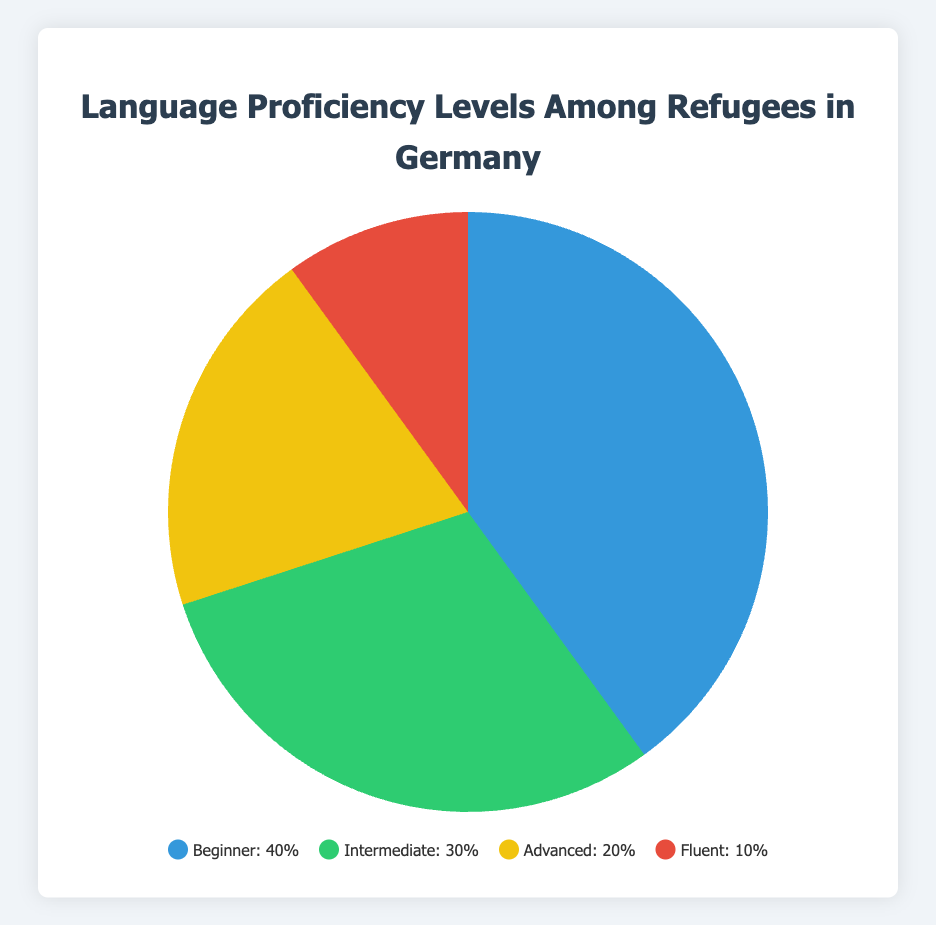What's the most common language proficiency level among refugees in Germany? The data shows that the highest percentage is 40%, attributed to the Beginner level, indicating that it is the most common proficiency level among refugees.
Answer: Beginner Which language proficiency level has the smallest percentage? The data indicates that the Fluent level has the smallest percentage at 10%.
Answer: Fluent What is the combined percentage of Intermediate and Advanced proficiency levels? The Intermediate level is 30% and the Advanced level is 20%. Adding them together gives 30% + 20% = 50%.
Answer: 50% What is the difference in percentage between the Beginner and Fluent proficiency levels? The Beginner level is 40%, and the Fluent level is 10%. The difference is 40% - 10% = 30%.
Answer: 30% What percentage is represented by the Beginner and Fluent levels combined? The Beginner level is 40%, and the Fluent level is 10%. Together, they represent 40% + 10% = 50%.
Answer: 50% How much more common is the Beginner level compared to the Advanced level? The Beginner level is at 40%, and the Advanced level is at 20%. The Beginner level is 20% more common than the Advanced level (40% - 20% = 20%).
Answer: 20% What percentage of refugees have at least an Intermediate proficiency level? The Intermediate, Advanced, and Fluent levels together account for 30% + 20% + 10% = 60%.
Answer: 60% Which proficiency level is represented by the blue color in the chart? Observing the visual attributes, the blue color corresponds to the Beginner proficiency level, which is 40%.
Answer: Beginner If we sum the percentages of the top two proficiency levels, what do we get? The top two proficiency levels by percentage are Beginner (40%) and Intermediate (30%). Summing them gives 40% + 30% = 70%.
Answer: 70% Is there a proficiency level that is twice as common as another one? Yes, the Beginner level (40%) is exactly twice as common as the Advanced level (20%).
Answer: Yes 